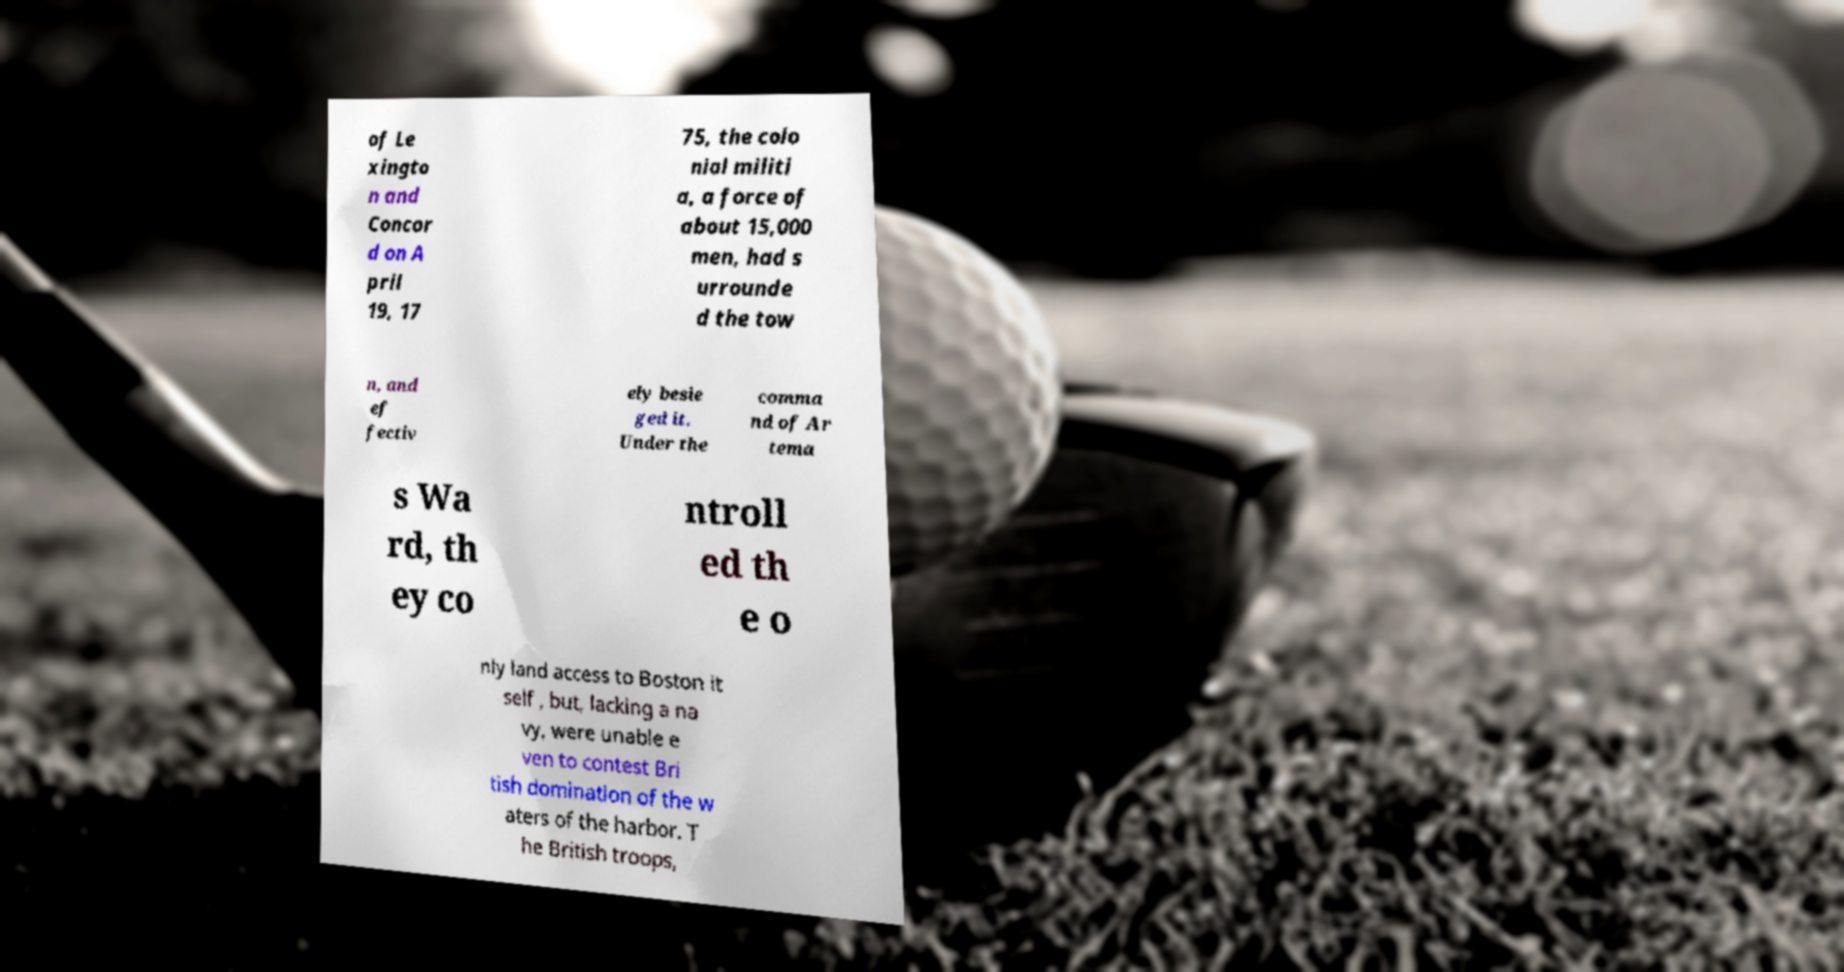I need the written content from this picture converted into text. Can you do that? of Le xingto n and Concor d on A pril 19, 17 75, the colo nial militi a, a force of about 15,000 men, had s urrounde d the tow n, and ef fectiv ely besie ged it. Under the comma nd of Ar tema s Wa rd, th ey co ntroll ed th e o nly land access to Boston it self , but, lacking a na vy, were unable e ven to contest Bri tish domination of the w aters of the harbor. T he British troops, 